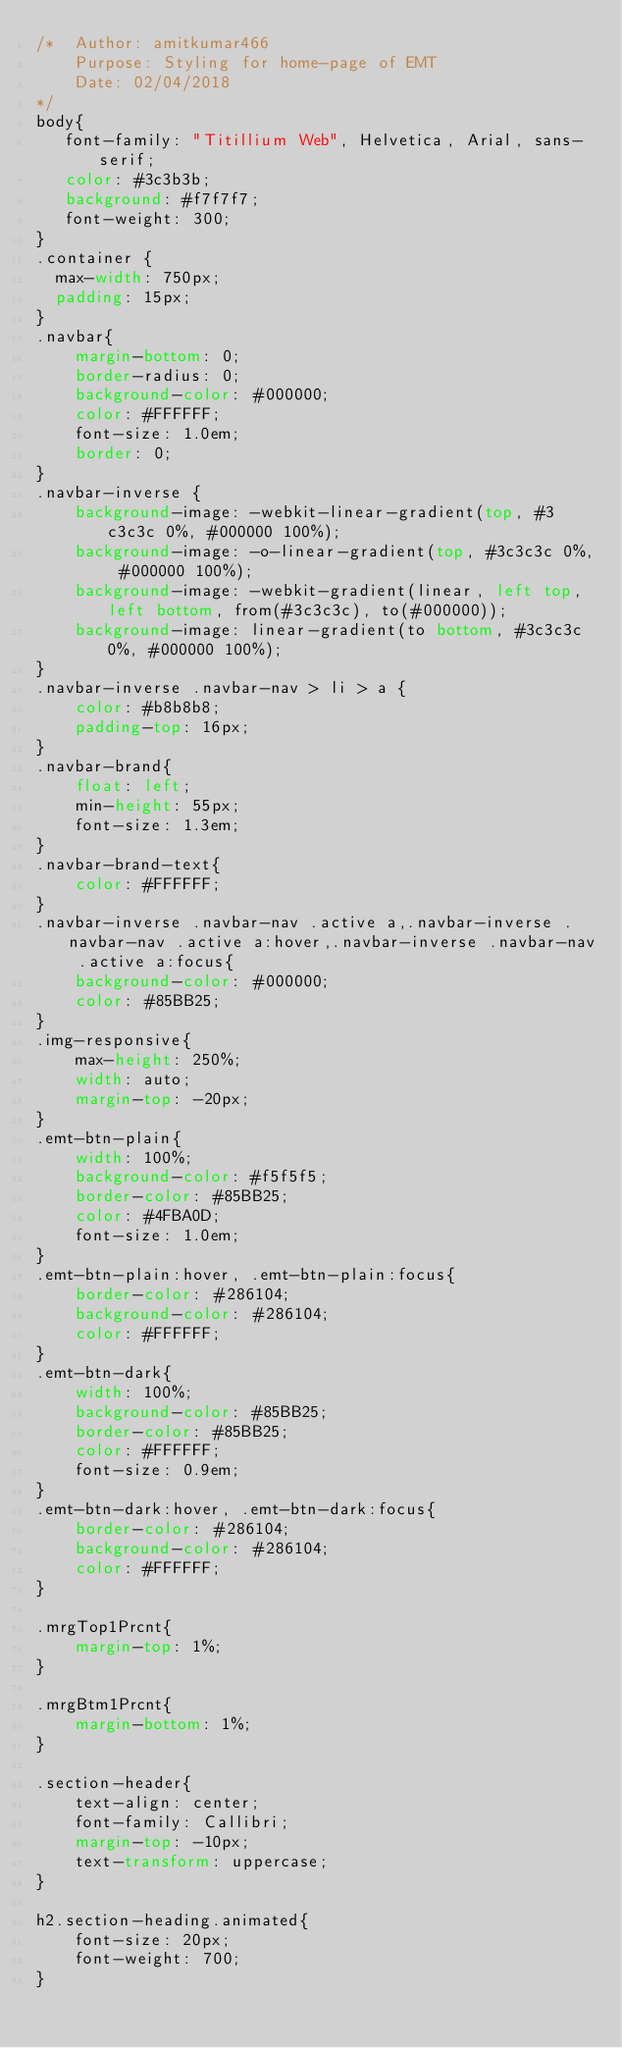Convert code to text. <code><loc_0><loc_0><loc_500><loc_500><_CSS_>/*  Author: amitkumar466 
	Purpose: Styling for home-page of EMT
	Date: 02/04/2018
*/
body{
   font-family: "Titillium Web", Helvetica, Arial, sans-serif;
   color: #3c3b3b;
   background: #f7f7f7;
   font-weight: 300;
}
.container {
  max-width: 750px;
  padding: 15px;
}
.navbar{
	margin-bottom: 0;
	border-radius: 0;
	background-color: #000000;
	color: #FFFFFF;
	font-size: 1.0em;
	border: 0;
}
.navbar-inverse {
    background-image: -webkit-linear-gradient(top, #3c3c3c 0%, #000000 100%);
    background-image: -o-linear-gradient(top, #3c3c3c 0%, #000000 100%);
    background-image: -webkit-gradient(linear, left top, left bottom, from(#3c3c3c), to(#000000));
    background-image: linear-gradient(to bottom, #3c3c3c 0%, #000000 100%);
}
.navbar-inverse .navbar-nav > li > a {
    color: #b8b8b8;
    padding-top: 16px;
}
.navbar-brand{
	float: left;
	min-height: 55px;
	font-size: 1.3em;
}
.navbar-brand-text{
	color: #FFFFFF;
}
.navbar-inverse .navbar-nav .active a,.navbar-inverse .navbar-nav .active a:hover,.navbar-inverse .navbar-nav .active a:focus{
	background-color: #000000;
	color: #85BB25;
}
.img-responsive{
	max-height: 250%;
    width: auto;
    margin-top: -20px;
}
.emt-btn-plain{
	width: 100%;
	background-color: #f5f5f5;
	border-color: #85BB25;
	color: #4FBA0D;
	font-size: 1.0em;
}
.emt-btn-plain:hover, .emt-btn-plain:focus{
	border-color: #286104;
	background-color: #286104;
	color: #FFFFFF;
}
.emt-btn-dark{
	width: 100%;
	background-color: #85BB25;
	border-color: #85BB25;
	color: #FFFFFF;
	font-size: 0.9em;
}
.emt-btn-dark:hover, .emt-btn-dark:focus{
	border-color: #286104;
	background-color: #286104;
	color: #FFFFFF;
}

.mrgTop1Prcnt{
	margin-top: 1%;
}

.mrgBtm1Prcnt{
	margin-bottom: 1%;
}

.section-header{
	text-align: center;	
	font-family: Callibri;
    margin-top: -10px;
    text-transform: uppercase;
}

h2.section-heading.animated{
	font-size: 20px;
	font-weight: 700;
}
</code> 